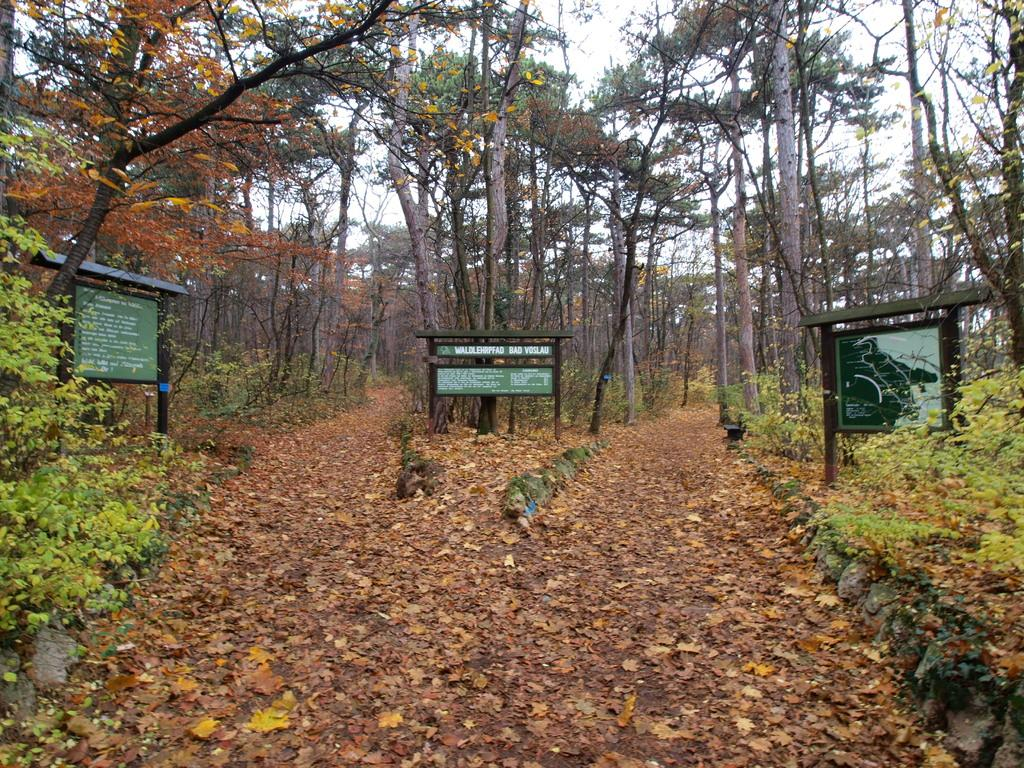What is the main subject in the center of the image? There are green color boards in the center of the image. What can be seen on the boards? Something is written on the boards. What type of natural environment is visible in the image? There are trees visible in the image. What is present on the ground in the image? Leaves are present on the ground. What type of nut is visible on the ground in the image? There is no nut visible on the ground in the image. Is there a cable running through the trees in the image? There is no cable visible in the image. 